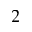<formula> <loc_0><loc_0><loc_500><loc_500>^ { 2 }</formula> 